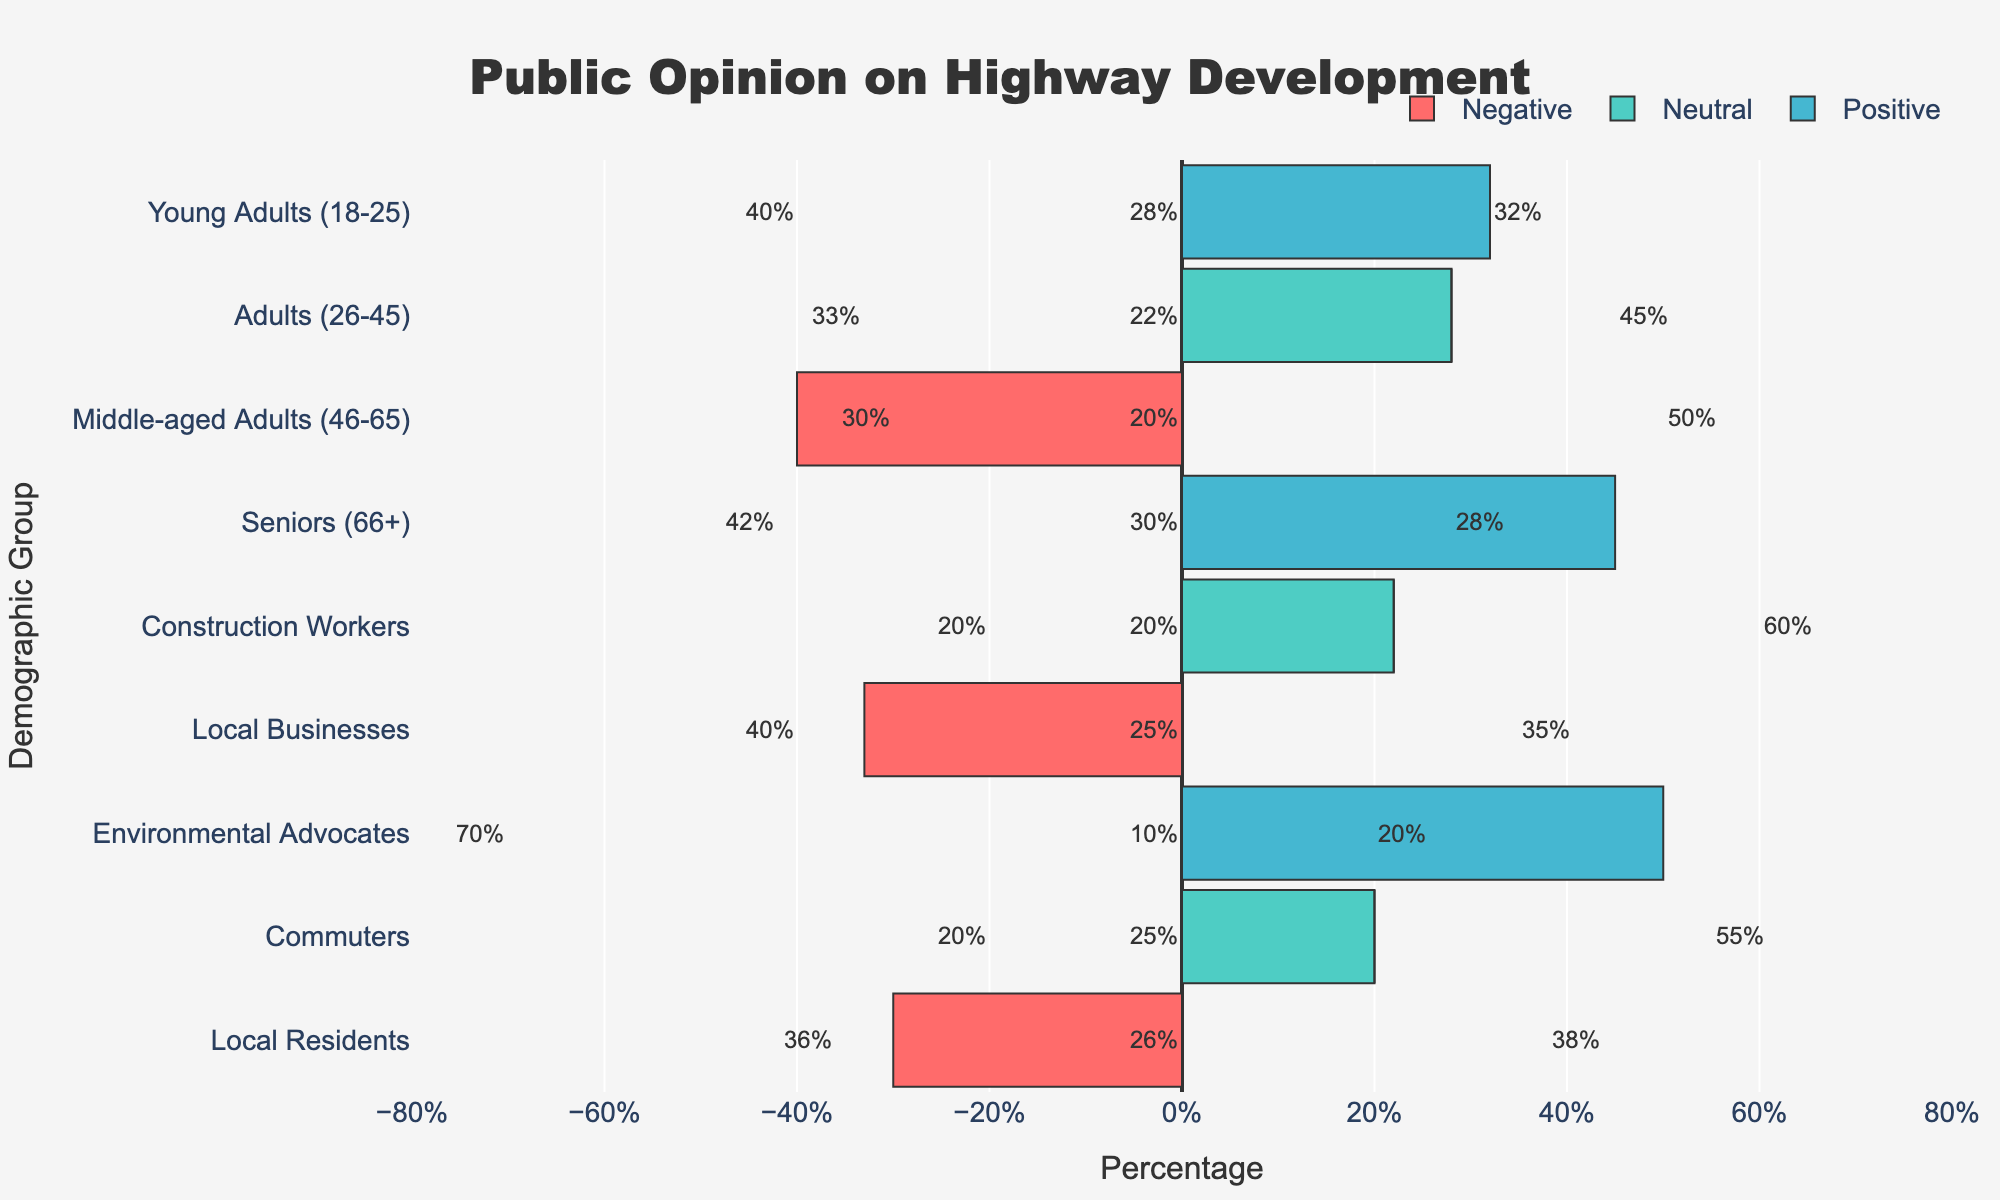Which demographic group has the highest positive sentiment? Looking at the blue bars representing positive sentiment, the construction workers’ bar stands out as the tallest.
Answer: Construction Workers Which group has the most negative sentiment? The red bars represent negative sentiment. Among these, the bar for environmental advocates is the longest, indicating the highest negative sentiment.
Answer: Environmental Advocates How many groups have a higher percentage of positive sentiment than negative sentiment? By comparing the lengths of the blue and red bars for each group, we can count that the following groups have a higher positive sentiment than negative sentiment: Adults (26-45), Middle-aged Adults (46-65), Construction Workers, Commuters.
Answer: 4 Which groups have an equal percentage of neutral and negative sentiment? The neutral sentiment is represented by green bars and the negative sentiment by red bars. By visually comparing these bars for equality, only the Construction Workers group shows equal percentage values for neutral and negative sentiment.
Answer: Construction Workers By how many percentage points does the positive sentiment in commuters exceed that in young adults? The percentage of positive sentiment in commuters is 55%, and for young adults, it is 32%. The difference is 55% - 32% = 23%.
Answer: 23% In which group is the neutral sentiment closest to the positive sentiment, and what are these percentages? The group with the least difference between the green (neutral) and blue (positive) bars is Local Residents, where the percentages are 26% neutral and 38% positive.
Answer: Local Residents, 26% neutral, 38% positive Compare the negative sentiment in local businesses to that in local residents. Which one is lower, and by how much? The negative sentiment for local businesses is 40%, while for local residents, it is 36%. The negative sentiment is lower in local residents by 40% - 36% = 4%.
Answer: Local Residents, 4% lower What is the average positive sentiment percentage across all groups? By summing the positive sentiment percentages for all groups (32 + 45 + 50 + 28 + 60 + 35 + 20 + 55 + 38) and dividing by the number of groups (9), the average is (32 + 45 + 50 + 28 + 60 + 35 + 20 + 55 + 38) / 9 = 40.33%.
Answer: 40.33% Is the percentage of neutral sentiment more in the young adults or seniors group? Comparing the green bars, the neutral sentiment in young adults is 28% and in seniors is 30%.
Answer: Seniors 